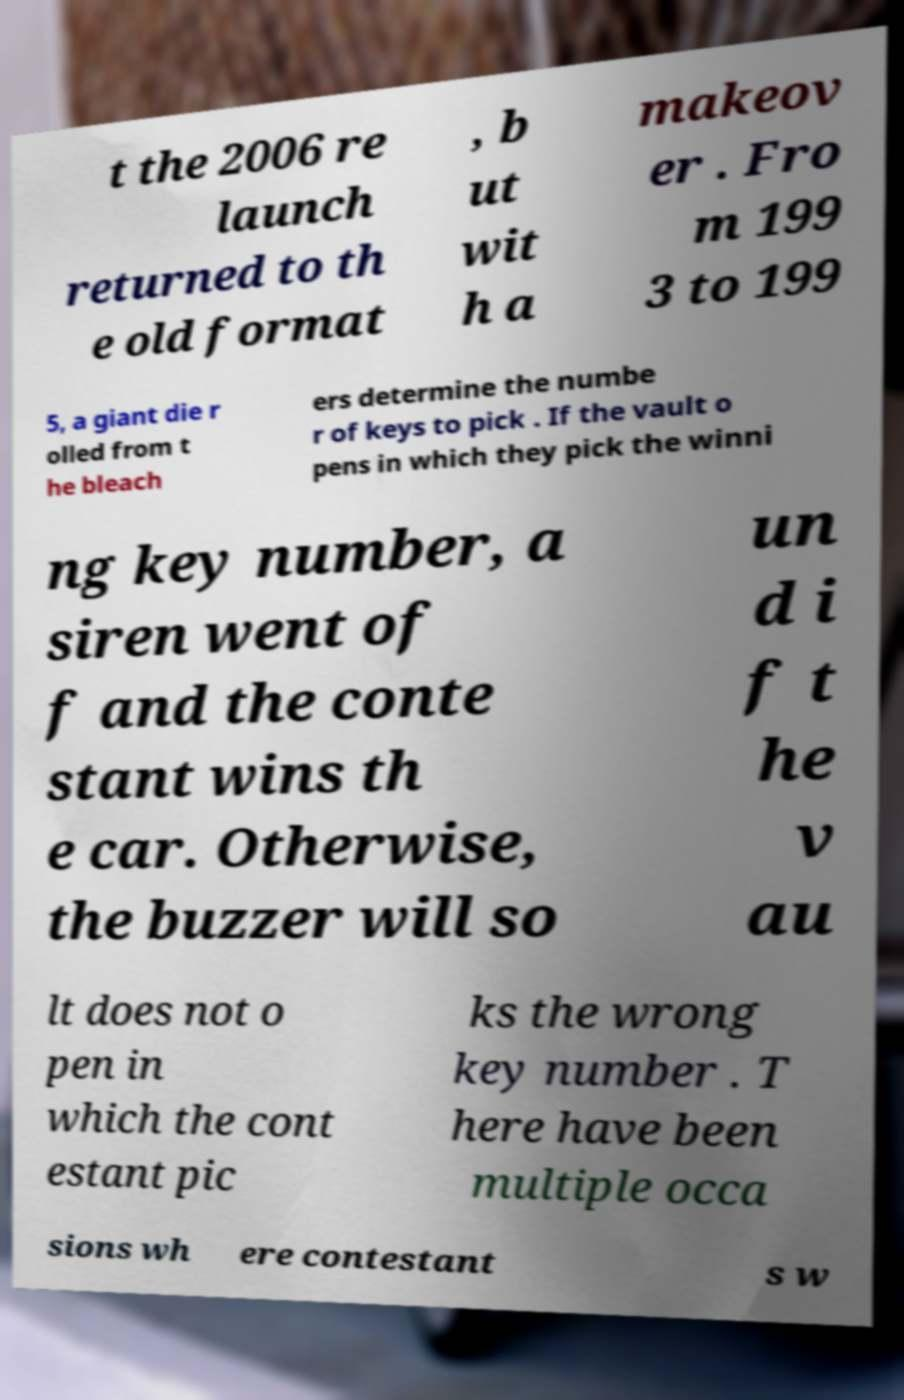Can you read and provide the text displayed in the image?This photo seems to have some interesting text. Can you extract and type it out for me? t the 2006 re launch returned to th e old format , b ut wit h a makeov er . Fro m 199 3 to 199 5, a giant die r olled from t he bleach ers determine the numbe r of keys to pick . If the vault o pens in which they pick the winni ng key number, a siren went of f and the conte stant wins th e car. Otherwise, the buzzer will so un d i f t he v au lt does not o pen in which the cont estant pic ks the wrong key number . T here have been multiple occa sions wh ere contestant s w 